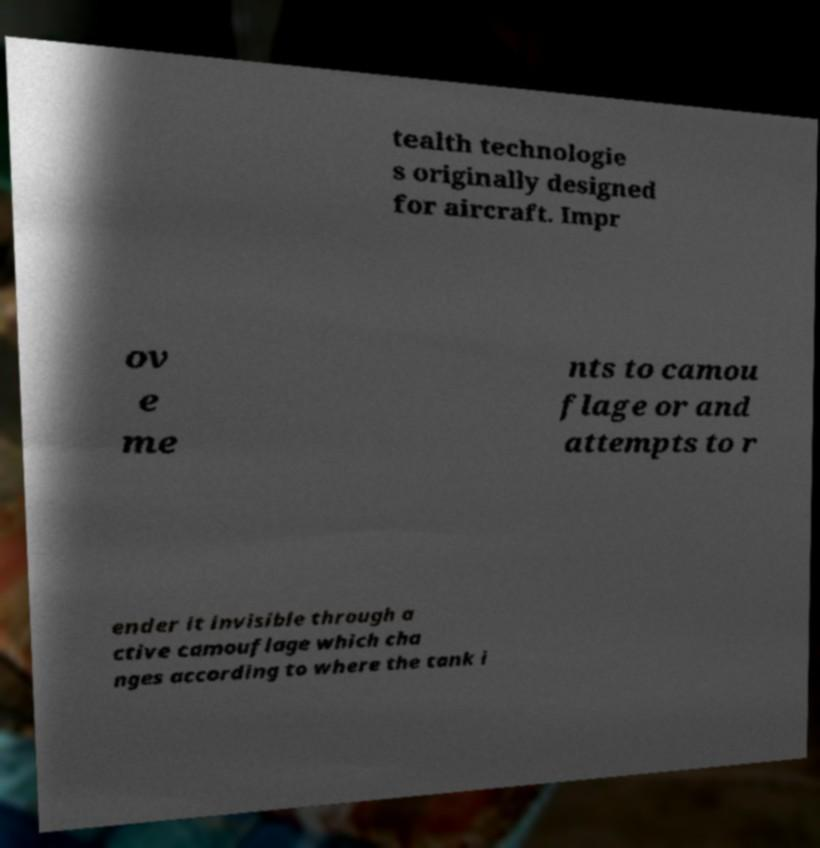I need the written content from this picture converted into text. Can you do that? tealth technologie s originally designed for aircraft. Impr ov e me nts to camou flage or and attempts to r ender it invisible through a ctive camouflage which cha nges according to where the tank i 